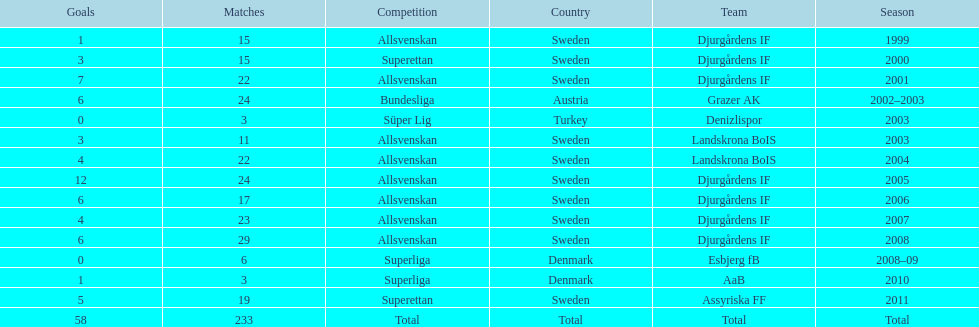How many matches did jones kusi-asare play in in his first season? 15. 